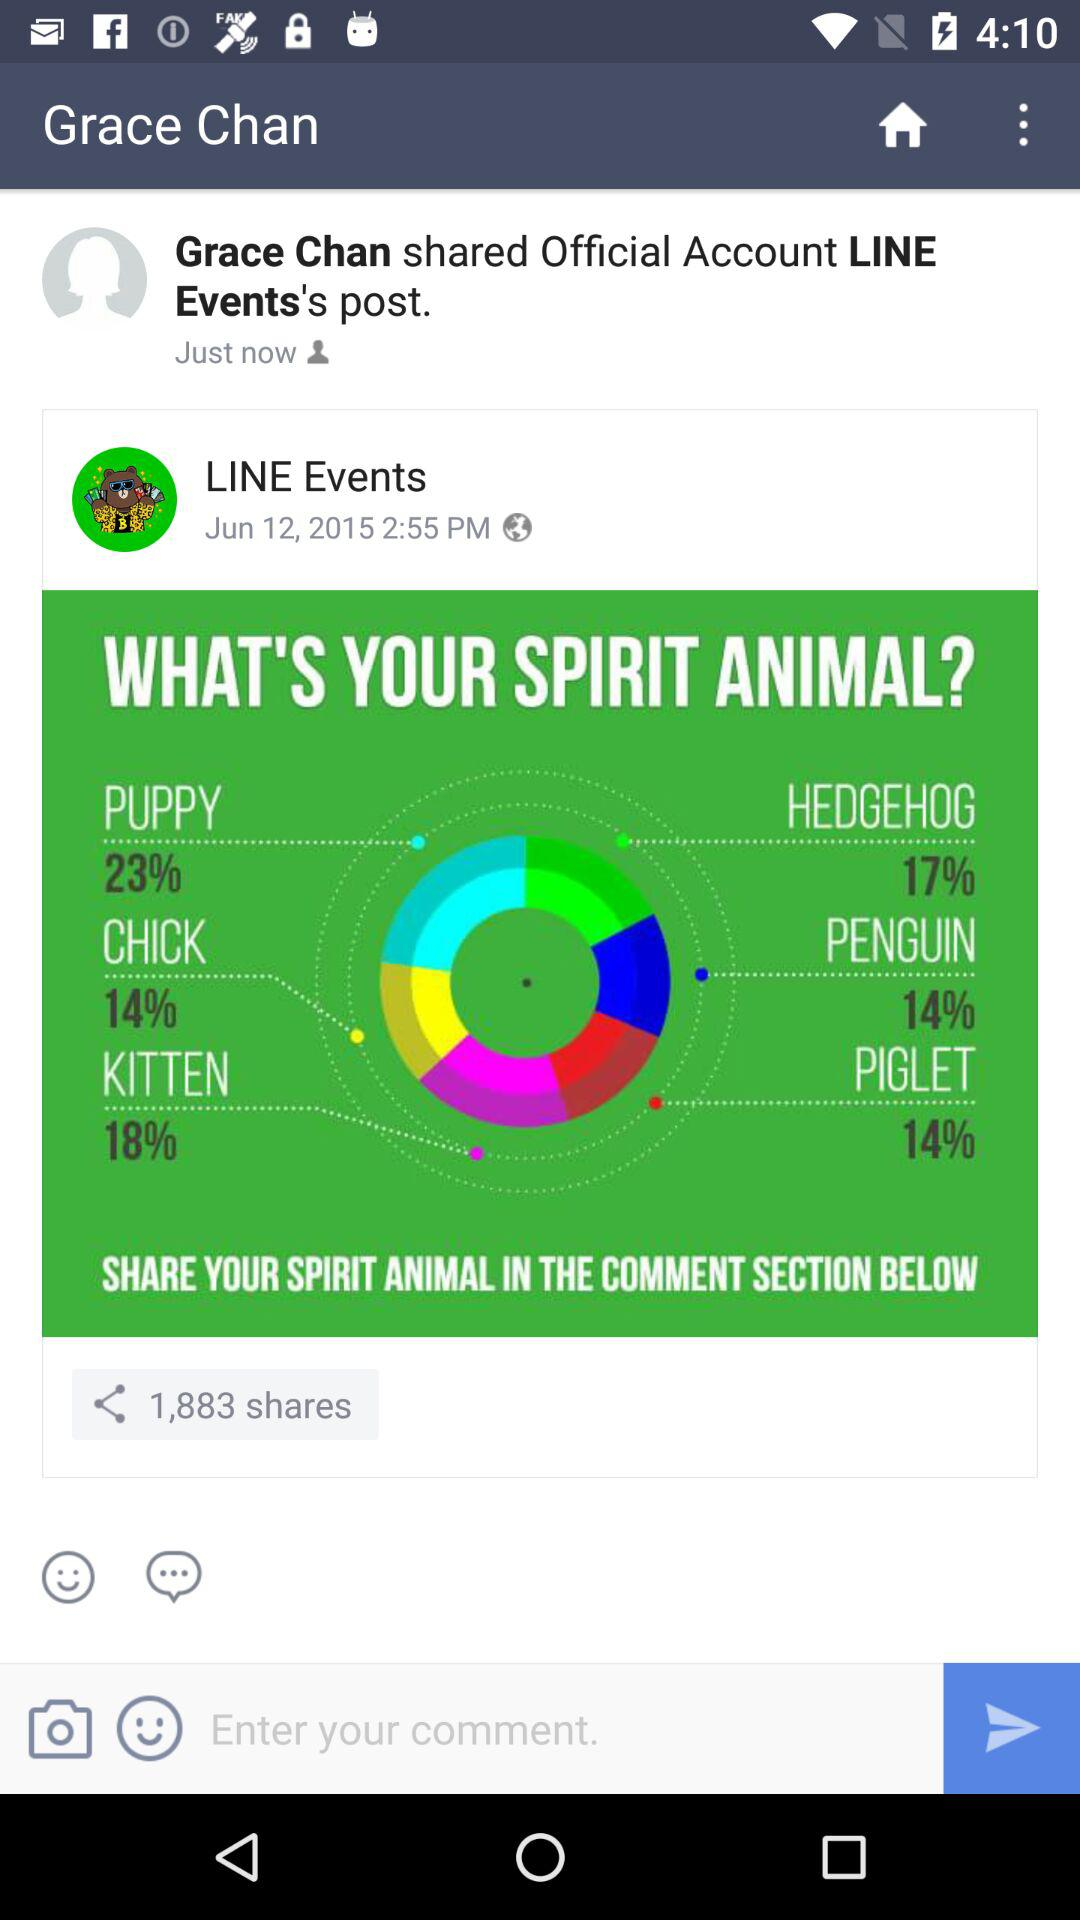What's the official account whose post was shared by Grace Chan? The official account is "LINE Events". 